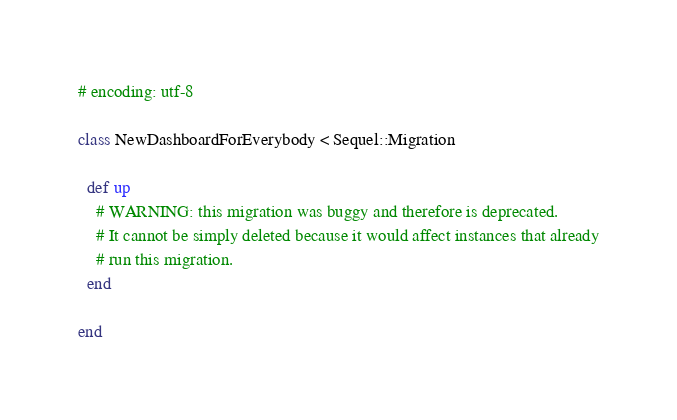<code> <loc_0><loc_0><loc_500><loc_500><_Ruby_># encoding: utf-8

class NewDashboardForEverybody < Sequel::Migration

  def up
    # WARNING: this migration was buggy and therefore is deprecated.
    # It cannot be simply deleted because it would affect instances that already
    # run this migration.
  end

end
</code> 